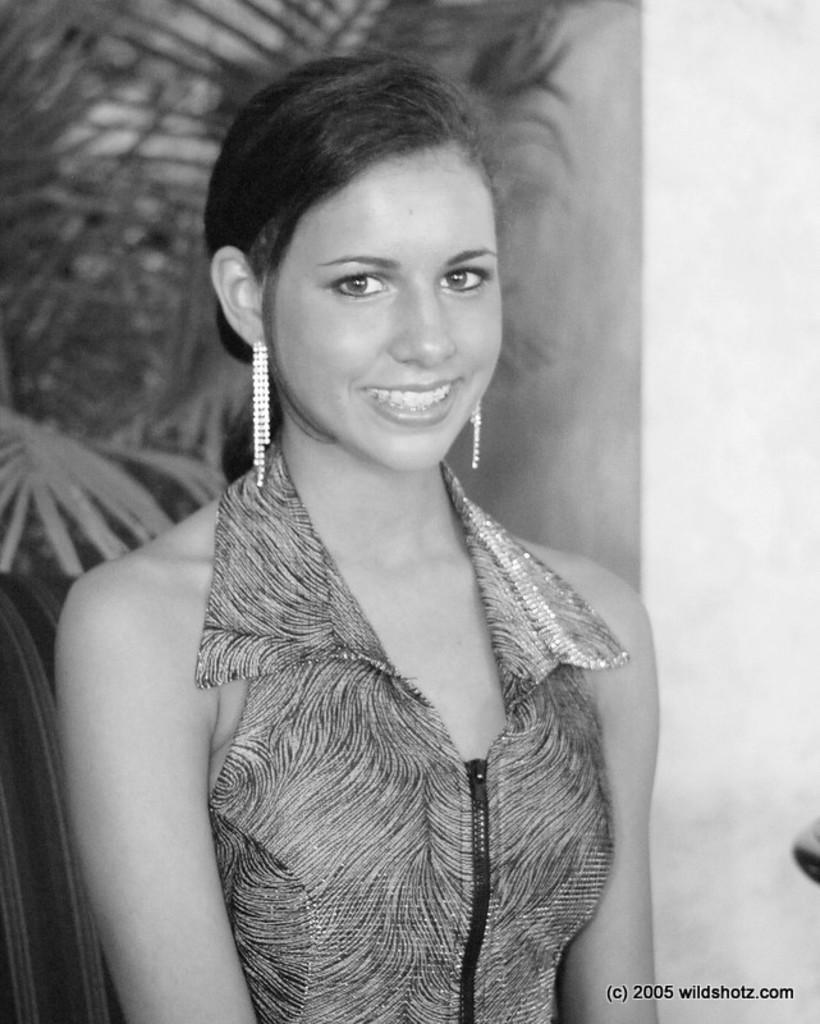Describe this image in one or two sentences. In this image there is a person wearing a smile on her face. Behind her there are trees. There is a wall. There is some text at the bottom of the image. 